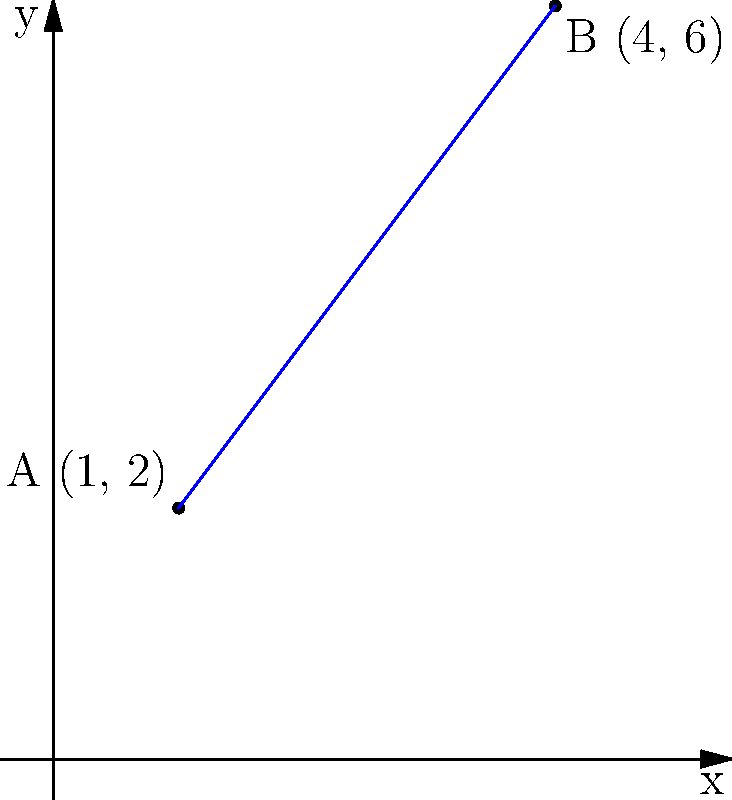Two significant protest locations from the Vietnam War era are represented on a coordinate plane. Point A (1, 2) represents the location of the 1965 teach-in at the University of Michigan, and Point B (4, 6) represents the site of the 1967 March on Washington. Determine the equation of the line passing through these two historic protest locations in slope-intercept form $(y = mx + b)$. To find the equation of the line passing through two points, we'll follow these steps:

1. Calculate the slope $(m)$ using the slope formula:
   $m = \frac{y_2 - y_1}{x_2 - x_1} = \frac{6 - 2}{4 - 1} = \frac{4}{3}$

2. Use the point-slope form of a line with either point. Let's use A (1, 2):
   $y - y_1 = m(x - x_1)$
   $y - 2 = \frac{4}{3}(x - 1)$

3. Expand the equation:
   $y - 2 = \frac{4}{3}x - \frac{4}{3}$

4. Solve for $y$ to get the slope-intercept form:
   $y = \frac{4}{3}x - \frac{4}{3} + 2$
   $y = \frac{4}{3}x + \frac{2}{3}$

Thus, the equation of the line in slope-intercept form is $y = \frac{4}{3}x + \frac{2}{3}$.
Answer: $y = \frac{4}{3}x + \frac{2}{3}$ 